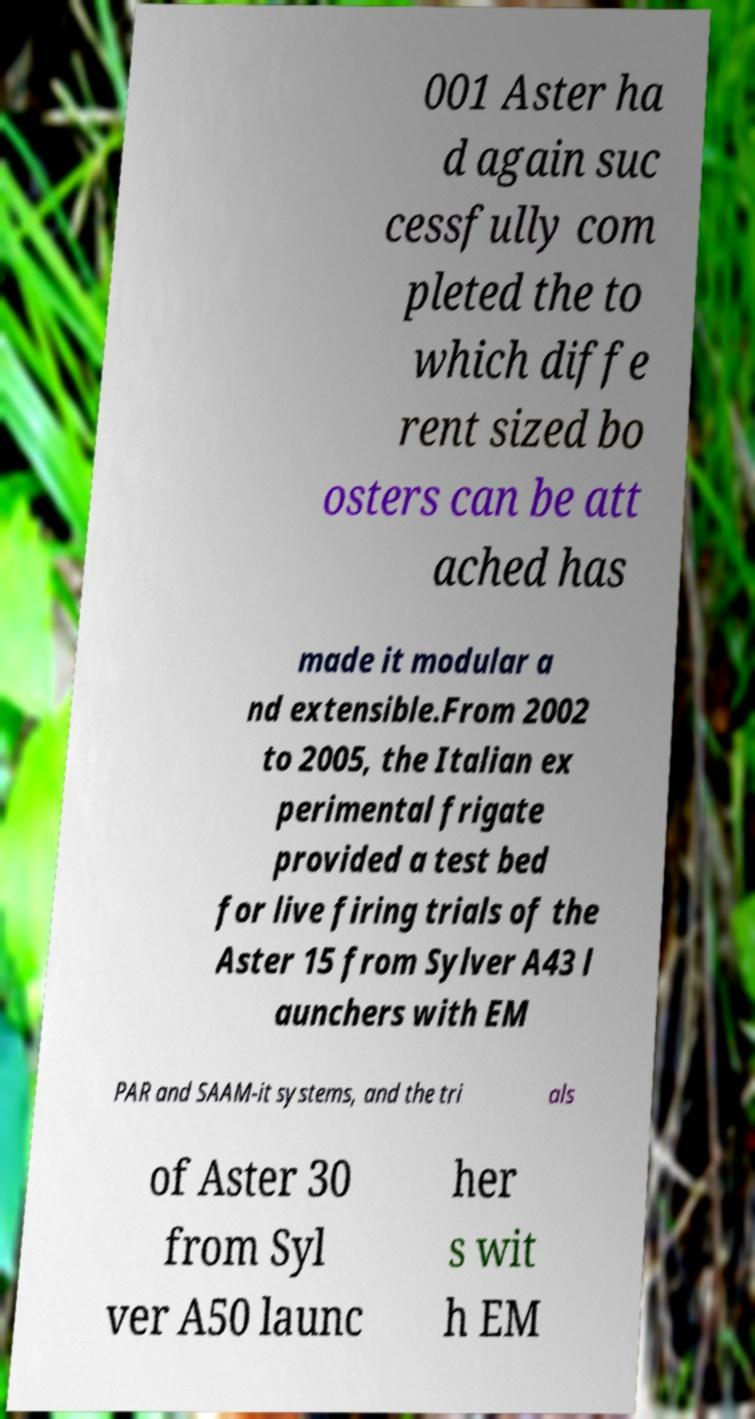What messages or text are displayed in this image? I need them in a readable, typed format. 001 Aster ha d again suc cessfully com pleted the to which diffe rent sized bo osters can be att ached has made it modular a nd extensible.From 2002 to 2005, the Italian ex perimental frigate provided a test bed for live firing trials of the Aster 15 from Sylver A43 l aunchers with EM PAR and SAAM-it systems, and the tri als of Aster 30 from Syl ver A50 launc her s wit h EM 